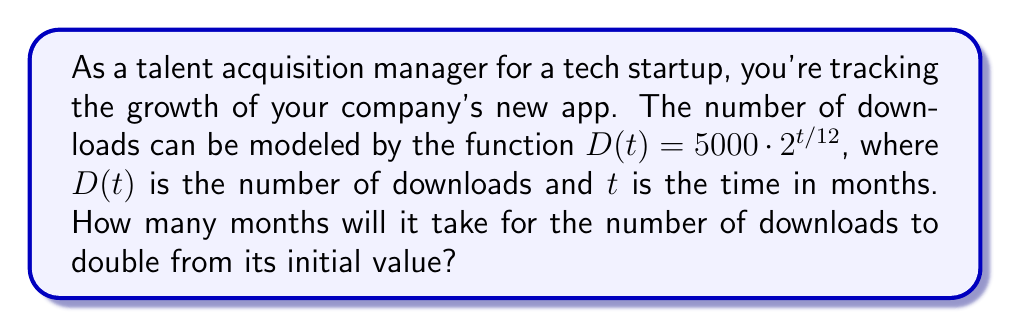Solve this math problem. Let's approach this step-by-step:

1) The initial number of downloads (at $t=0$) is:
   $D(0) = 5000 \cdot 2^{0/12} = 5000$

2) We want to find when the downloads reach twice this value:
   $2 \cdot D(0) = 2 \cdot 5000 = 10000$

3) So, we need to solve the equation:
   $5000 \cdot 2^{t/12} = 10000$

4) Dividing both sides by 5000:
   $2^{t/12} = 2$

5) Taking the logarithm (base 2) of both sides:
   $\log_2(2^{t/12}) = \log_2(2)$

6) Using the logarithm property $\log_a(a^x) = x$:
   $t/12 = 1$

7) Solving for $t$:
   $t = 12$

Therefore, it will take 12 months for the number of downloads to double.
Answer: 12 months 